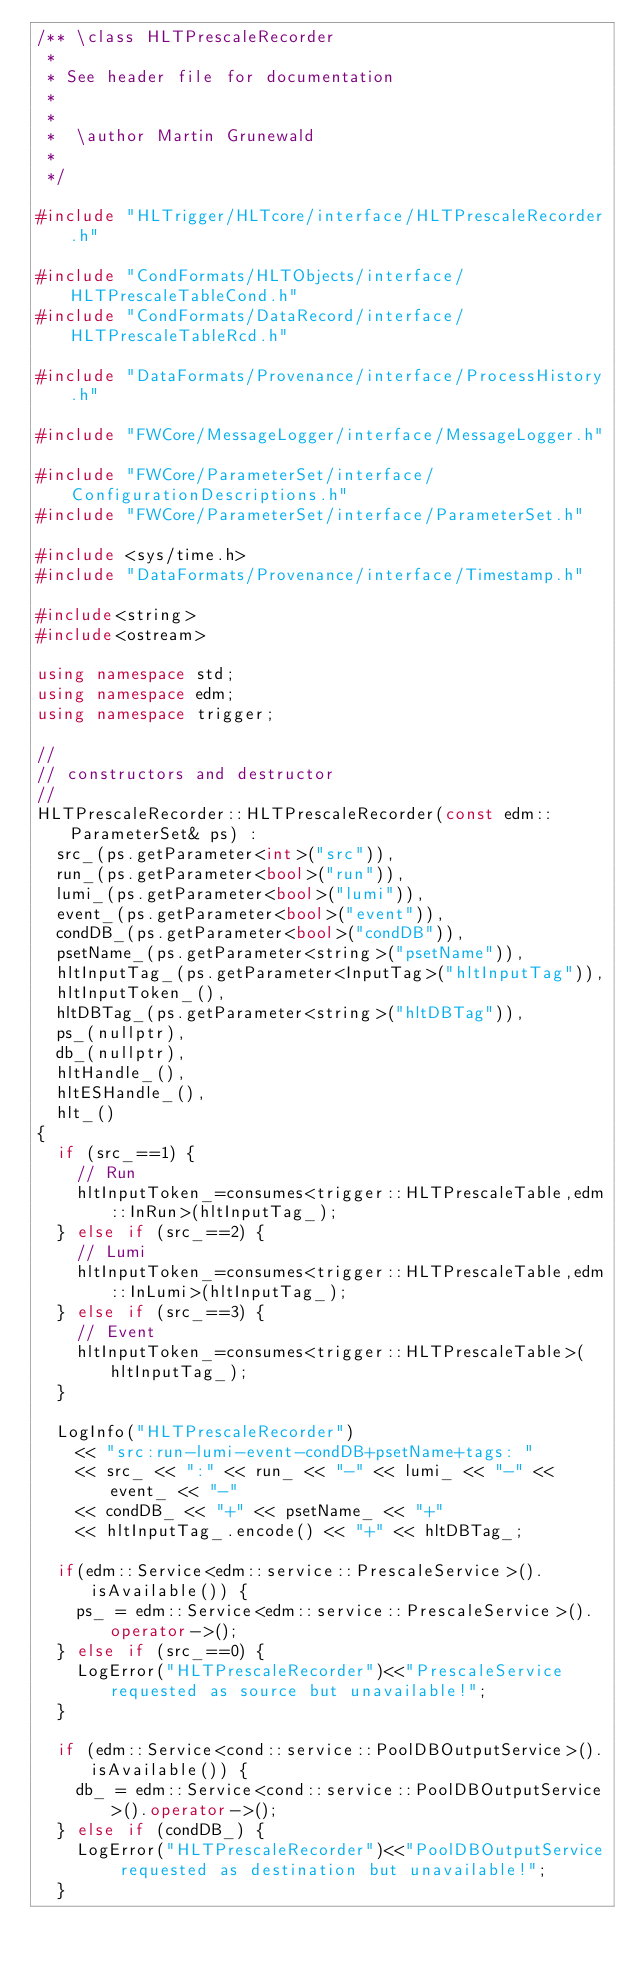<code> <loc_0><loc_0><loc_500><loc_500><_C++_>/** \class HLTPrescaleRecorder
 *
 * See header file for documentation
 *
 *
 *  \author Martin Grunewald
 *
 */

#include "HLTrigger/HLTcore/interface/HLTPrescaleRecorder.h"

#include "CondFormats/HLTObjects/interface/HLTPrescaleTableCond.h"
#include "CondFormats/DataRecord/interface/HLTPrescaleTableRcd.h"

#include "DataFormats/Provenance/interface/ProcessHistory.h"

#include "FWCore/MessageLogger/interface/MessageLogger.h"

#include "FWCore/ParameterSet/interface/ConfigurationDescriptions.h"
#include "FWCore/ParameterSet/interface/ParameterSet.h"

#include <sys/time.h>
#include "DataFormats/Provenance/interface/Timestamp.h"

#include<string>
#include<ostream>

using namespace std;
using namespace edm;
using namespace trigger;

//
// constructors and destructor
//
HLTPrescaleRecorder::HLTPrescaleRecorder(const edm::ParameterSet& ps) : 
  src_(ps.getParameter<int>("src")),
  run_(ps.getParameter<bool>("run")),
  lumi_(ps.getParameter<bool>("lumi")),
  event_(ps.getParameter<bool>("event")),
  condDB_(ps.getParameter<bool>("condDB")),
  psetName_(ps.getParameter<string>("psetName")),
  hltInputTag_(ps.getParameter<InputTag>("hltInputTag")),
  hltInputToken_(),
  hltDBTag_(ps.getParameter<string>("hltDBTag")),
  ps_(nullptr),
  db_(nullptr),
  hltHandle_(),
  hltESHandle_(),
  hlt_()
{
  if (src_==1) {
    // Run
    hltInputToken_=consumes<trigger::HLTPrescaleTable,edm::InRun>(hltInputTag_);
  } else if (src_==2) {
    // Lumi
    hltInputToken_=consumes<trigger::HLTPrescaleTable,edm::InLumi>(hltInputTag_);
  } else if (src_==3) {
    // Event
    hltInputToken_=consumes<trigger::HLTPrescaleTable>(hltInputTag_);
  }

  LogInfo("HLTPrescaleRecorder")
    << "src:run-lumi-event-condDB+psetName+tags: "
    << src_ << ":" << run_ << "-" << lumi_ << "-" << event_ << "-"
    << condDB_ << "+" << psetName_ << "+"
    << hltInputTag_.encode() << "+" << hltDBTag_;

  if(edm::Service<edm::service::PrescaleService>().isAvailable()) {
    ps_ = edm::Service<edm::service::PrescaleService>().operator->();
  } else if (src_==0) {
    LogError("HLTPrescaleRecorder")<<"PrescaleService requested as source but unavailable!";
  }

  if (edm::Service<cond::service::PoolDBOutputService>().isAvailable()) {
    db_ = edm::Service<cond::service::PoolDBOutputService>().operator->();
  } else if (condDB_) {
    LogError("HLTPrescaleRecorder")<<"PoolDBOutputService requested as destination but unavailable!";
  }
</code> 